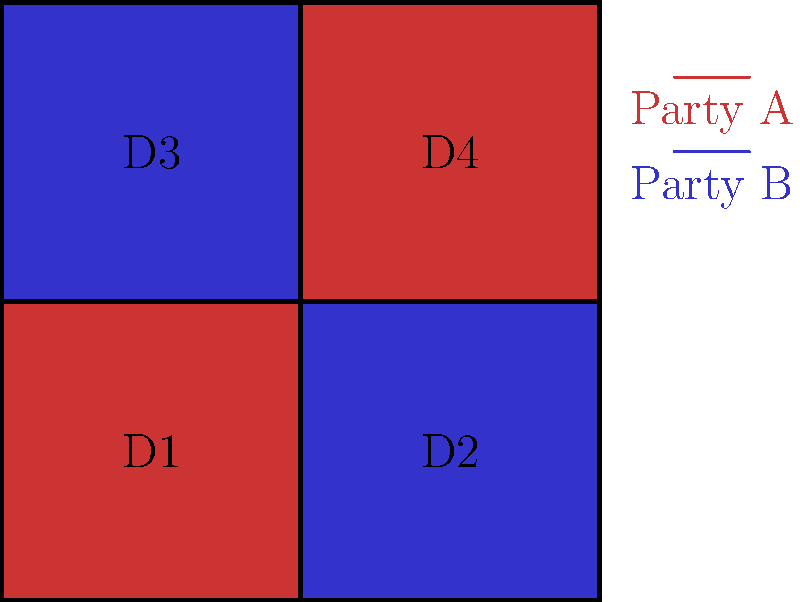In a local election, four districts (D1, D2, D3, and D4) show different voting patterns for Party A and Party B. Given that each district has an equal number of voters and the winning party in each district is shown by its color (red for Party A, blue for Party B), what is the minimum percentage of the total popular vote that Party B could have received while still winning the majority of districts? To solve this problem, we need to follow these steps:

1. Identify the number of districts won by each party:
   Party A won 2 districts (D1 and D4)
   Party B won 2 districts (D2 and D3)

2. Determine the minimum scenario for Party B to win the majority of districts:
   Party B needs to win 3 out of 4 districts

3. Calculate the minimum votes needed in each district:
   To win a district, a party needs 50% + 1 vote
   Let's assume each district has 100 voters for simplicity
   Minimum votes to win a district = 51 votes

4. Set up the minimum winning scenario for Party B:
   Win 3 districts with 51 votes each: 51 * 3 = 153 votes
   Lose 1 district with 0 votes

5. Calculate the total votes across all districts:
   Total votes = 100 voters * 4 districts = 400 votes

6. Calculate the minimum percentage of the popular vote for Party B:
   Minimum percentage = (Party B votes / Total votes) * 100
   Minimum percentage = (153 / 400) * 100 = 38.25%

Therefore, Party B could win the majority of districts (3 out of 4) with a minimum of 38.25% of the total popular vote.
Answer: 38.25% 